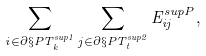<formula> <loc_0><loc_0><loc_500><loc_500>\sum _ { i \in \partial \S P T _ { k } ^ { s u p { 1 } } } \sum _ { j \in \partial \S P T _ { t } ^ { s u p { 2 } } } E ^ { s u p { P } } _ { i j } ,</formula> 